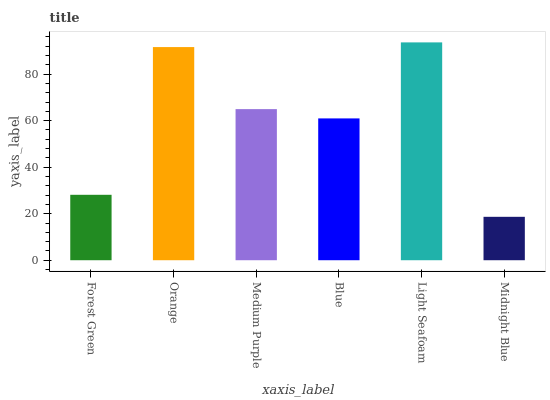Is Midnight Blue the minimum?
Answer yes or no. Yes. Is Light Seafoam the maximum?
Answer yes or no. Yes. Is Orange the minimum?
Answer yes or no. No. Is Orange the maximum?
Answer yes or no. No. Is Orange greater than Forest Green?
Answer yes or no. Yes. Is Forest Green less than Orange?
Answer yes or no. Yes. Is Forest Green greater than Orange?
Answer yes or no. No. Is Orange less than Forest Green?
Answer yes or no. No. Is Medium Purple the high median?
Answer yes or no. Yes. Is Blue the low median?
Answer yes or no. Yes. Is Orange the high median?
Answer yes or no. No. Is Forest Green the low median?
Answer yes or no. No. 